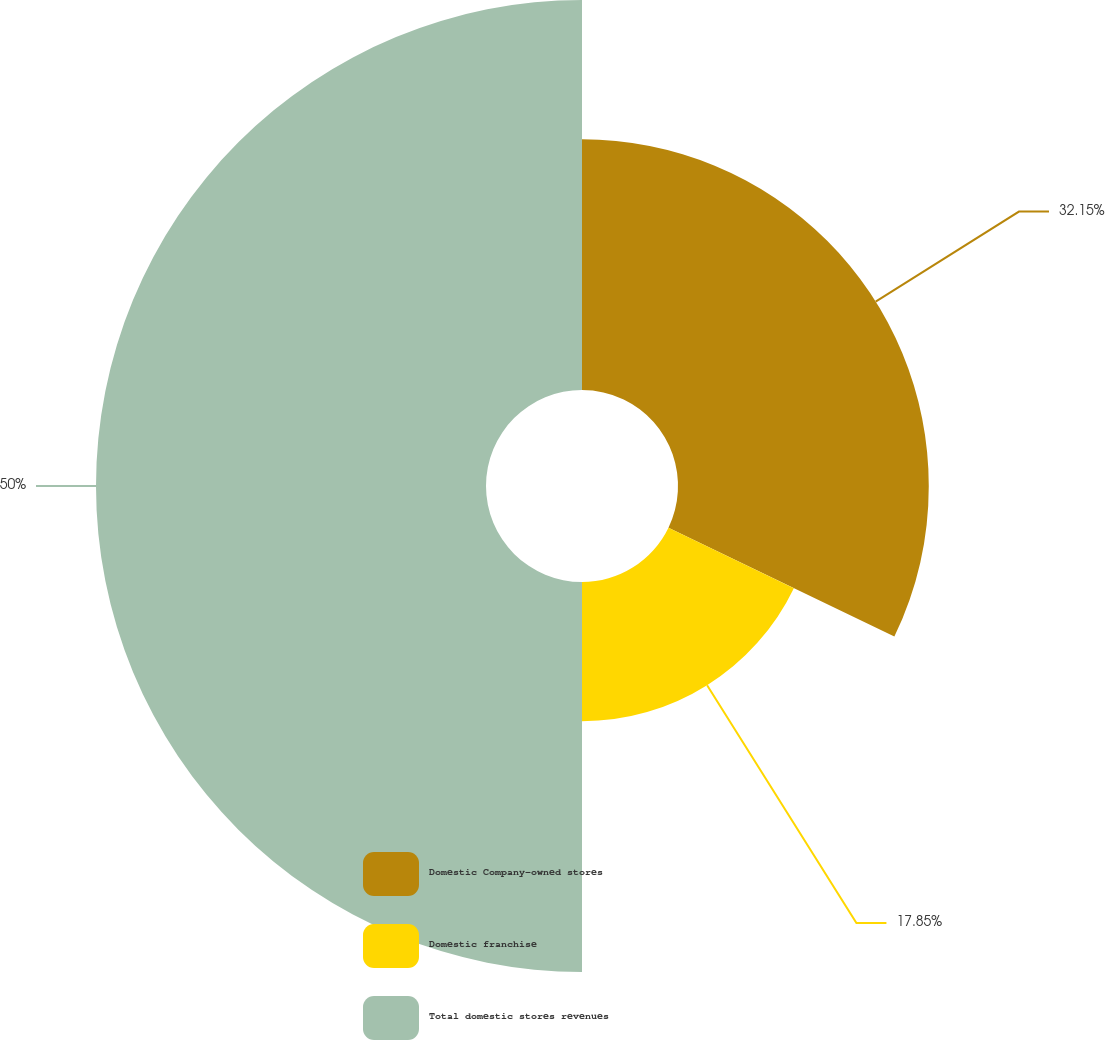Convert chart. <chart><loc_0><loc_0><loc_500><loc_500><pie_chart><fcel>Domestic Company-owned stores<fcel>Domestic franchise<fcel>Total domestic stores revenues<nl><fcel>32.15%<fcel>17.85%<fcel>50.0%<nl></chart> 